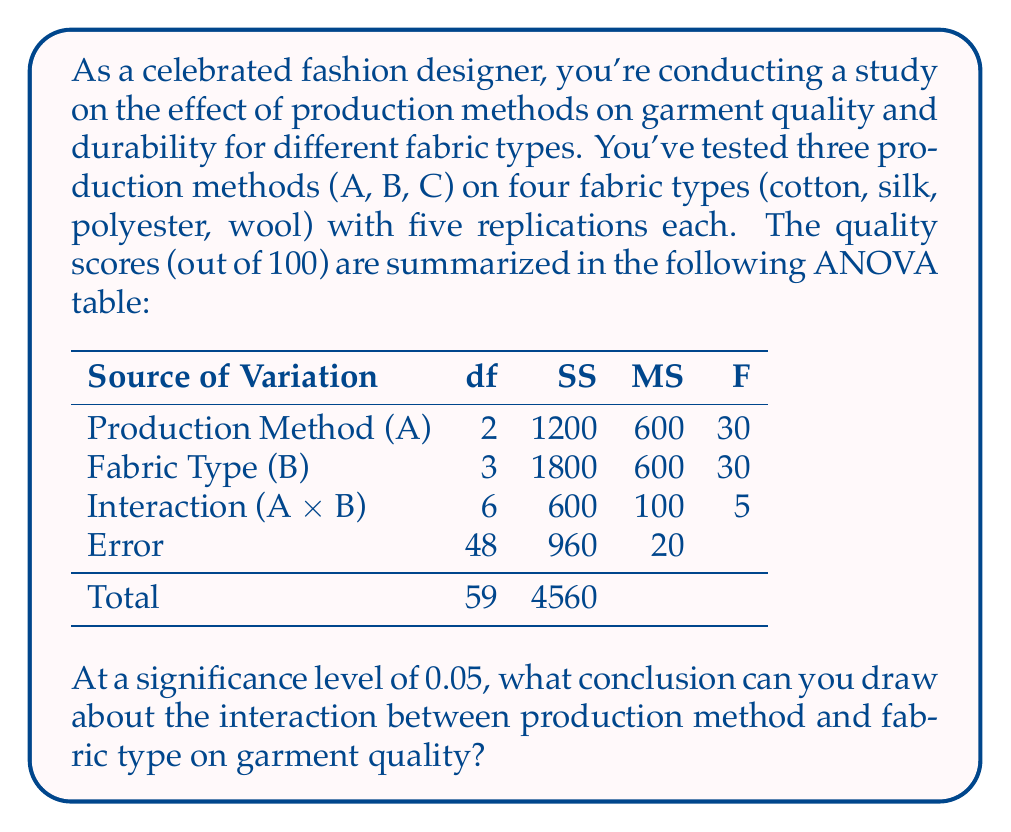Show me your answer to this math problem. To determine if there's a significant interaction between production method and fabric type, we need to follow these steps:

1) Identify the F-statistic for the interaction:
   From the ANOVA table, F = 5 for the interaction effect.

2) Determine the degrees of freedom:
   - Numerator df = 6 (from the Interaction row)
   - Denominator df = 48 (from the Error row)

3) Find the critical F-value:
   At α = 0.05, with df_numerator = 6 and df_denominator = 48, 
   F_critical ≈ 2.29 (from an F-distribution table)

4) Compare the F-statistic to the critical F-value:
   F_calculated (5) > F_critical (2.29)

5) Make a decision:
   Since F_calculated > F_critical, we reject the null hypothesis.

6) Interpret the result:
   Rejecting the null hypothesis means that there is a significant interaction effect between production method and fabric type on garment quality at the 0.05 significance level.

This suggests that the effect of production method on garment quality depends on the fabric type being used, or vice versa. As a fashion designer, this implies that you need to consider both factors together when making decisions about production processes for different fabrics to optimize garment quality.
Answer: Significant interaction effect exists between production method and fabric type on garment quality (p < 0.05). 